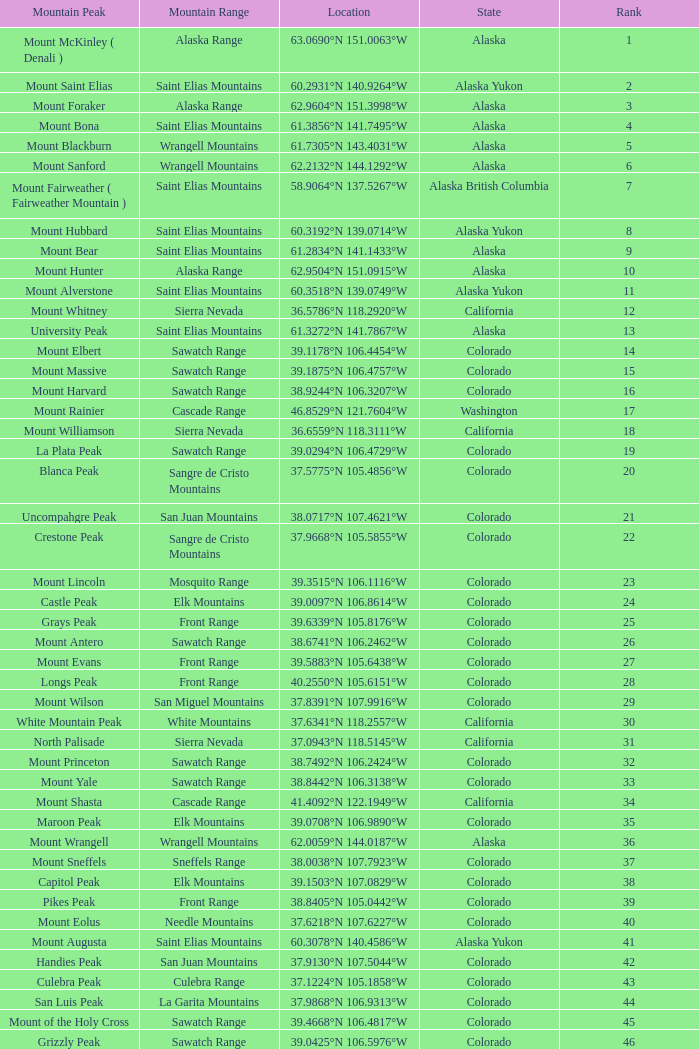What is the mountain peak when the location is 37.5775°n 105.4856°w? Blanca Peak. 